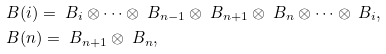Convert formula to latex. <formula><loc_0><loc_0><loc_500><loc_500>& \ B ( i ) = \ B _ { i } \otimes \cdots \otimes \ B _ { n - 1 } \otimes \ B _ { n + 1 } \otimes \ B _ { n } \otimes \cdots \otimes \ B _ { i } , \\ & \ B ( n ) = \ B _ { n + 1 } \otimes \ B _ { n } ,</formula> 